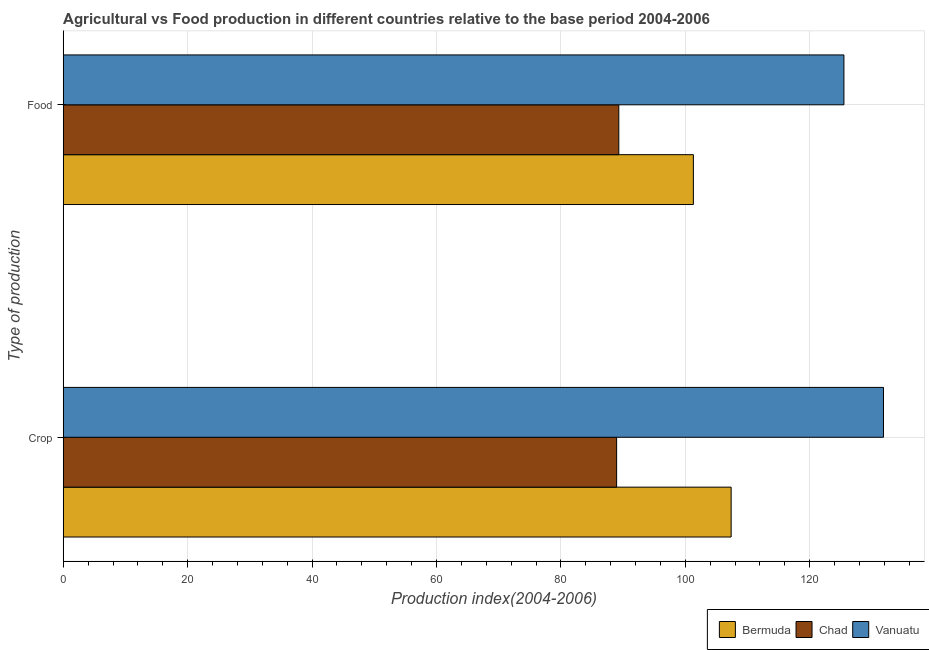How many bars are there on the 2nd tick from the bottom?
Your answer should be very brief. 3. What is the label of the 2nd group of bars from the top?
Keep it short and to the point. Crop. What is the food production index in Vanuatu?
Offer a very short reply. 125.5. Across all countries, what is the maximum crop production index?
Your response must be concise. 131.86. Across all countries, what is the minimum food production index?
Your answer should be very brief. 89.31. In which country was the food production index maximum?
Your answer should be compact. Vanuatu. In which country was the food production index minimum?
Your answer should be compact. Chad. What is the total food production index in the graph?
Your response must be concise. 316.11. What is the difference between the crop production index in Chad and that in Bermuda?
Your response must be concise. -18.41. What is the difference between the crop production index in Chad and the food production index in Vanuatu?
Offer a terse response. -36.54. What is the average food production index per country?
Offer a very short reply. 105.37. What is the difference between the food production index and crop production index in Chad?
Offer a very short reply. 0.35. In how many countries, is the food production index greater than 124 ?
Your answer should be very brief. 1. What is the ratio of the food production index in Vanuatu to that in Bermuda?
Provide a succinct answer. 1.24. Is the food production index in Vanuatu less than that in Bermuda?
Keep it short and to the point. No. What does the 1st bar from the top in Food represents?
Ensure brevity in your answer.  Vanuatu. What does the 1st bar from the bottom in Crop represents?
Provide a succinct answer. Bermuda. How many bars are there?
Keep it short and to the point. 6. Are all the bars in the graph horizontal?
Make the answer very short. Yes. Are the values on the major ticks of X-axis written in scientific E-notation?
Your answer should be very brief. No. Does the graph contain any zero values?
Your answer should be compact. No. Where does the legend appear in the graph?
Ensure brevity in your answer.  Bottom right. How are the legend labels stacked?
Your answer should be very brief. Horizontal. What is the title of the graph?
Make the answer very short. Agricultural vs Food production in different countries relative to the base period 2004-2006. What is the label or title of the X-axis?
Provide a short and direct response. Production index(2004-2006). What is the label or title of the Y-axis?
Provide a short and direct response. Type of production. What is the Production index(2004-2006) in Bermuda in Crop?
Give a very brief answer. 107.37. What is the Production index(2004-2006) of Chad in Crop?
Your response must be concise. 88.96. What is the Production index(2004-2006) in Vanuatu in Crop?
Ensure brevity in your answer.  131.86. What is the Production index(2004-2006) in Bermuda in Food?
Your response must be concise. 101.3. What is the Production index(2004-2006) in Chad in Food?
Provide a short and direct response. 89.31. What is the Production index(2004-2006) of Vanuatu in Food?
Your response must be concise. 125.5. Across all Type of production, what is the maximum Production index(2004-2006) of Bermuda?
Offer a terse response. 107.37. Across all Type of production, what is the maximum Production index(2004-2006) of Chad?
Offer a very short reply. 89.31. Across all Type of production, what is the maximum Production index(2004-2006) in Vanuatu?
Your response must be concise. 131.86. Across all Type of production, what is the minimum Production index(2004-2006) in Bermuda?
Your answer should be very brief. 101.3. Across all Type of production, what is the minimum Production index(2004-2006) in Chad?
Provide a short and direct response. 88.96. Across all Type of production, what is the minimum Production index(2004-2006) of Vanuatu?
Make the answer very short. 125.5. What is the total Production index(2004-2006) in Bermuda in the graph?
Your answer should be compact. 208.67. What is the total Production index(2004-2006) in Chad in the graph?
Give a very brief answer. 178.27. What is the total Production index(2004-2006) of Vanuatu in the graph?
Your response must be concise. 257.36. What is the difference between the Production index(2004-2006) of Bermuda in Crop and that in Food?
Offer a very short reply. 6.07. What is the difference between the Production index(2004-2006) in Chad in Crop and that in Food?
Offer a terse response. -0.35. What is the difference between the Production index(2004-2006) in Vanuatu in Crop and that in Food?
Your answer should be compact. 6.36. What is the difference between the Production index(2004-2006) in Bermuda in Crop and the Production index(2004-2006) in Chad in Food?
Offer a terse response. 18.06. What is the difference between the Production index(2004-2006) of Bermuda in Crop and the Production index(2004-2006) of Vanuatu in Food?
Keep it short and to the point. -18.13. What is the difference between the Production index(2004-2006) in Chad in Crop and the Production index(2004-2006) in Vanuatu in Food?
Offer a terse response. -36.54. What is the average Production index(2004-2006) of Bermuda per Type of production?
Provide a short and direct response. 104.33. What is the average Production index(2004-2006) of Chad per Type of production?
Make the answer very short. 89.14. What is the average Production index(2004-2006) of Vanuatu per Type of production?
Provide a short and direct response. 128.68. What is the difference between the Production index(2004-2006) of Bermuda and Production index(2004-2006) of Chad in Crop?
Ensure brevity in your answer.  18.41. What is the difference between the Production index(2004-2006) of Bermuda and Production index(2004-2006) of Vanuatu in Crop?
Keep it short and to the point. -24.49. What is the difference between the Production index(2004-2006) of Chad and Production index(2004-2006) of Vanuatu in Crop?
Ensure brevity in your answer.  -42.9. What is the difference between the Production index(2004-2006) in Bermuda and Production index(2004-2006) in Chad in Food?
Provide a short and direct response. 11.99. What is the difference between the Production index(2004-2006) of Bermuda and Production index(2004-2006) of Vanuatu in Food?
Make the answer very short. -24.2. What is the difference between the Production index(2004-2006) of Chad and Production index(2004-2006) of Vanuatu in Food?
Make the answer very short. -36.19. What is the ratio of the Production index(2004-2006) in Bermuda in Crop to that in Food?
Keep it short and to the point. 1.06. What is the ratio of the Production index(2004-2006) in Vanuatu in Crop to that in Food?
Provide a succinct answer. 1.05. What is the difference between the highest and the second highest Production index(2004-2006) in Bermuda?
Your response must be concise. 6.07. What is the difference between the highest and the second highest Production index(2004-2006) in Vanuatu?
Your response must be concise. 6.36. What is the difference between the highest and the lowest Production index(2004-2006) of Bermuda?
Offer a very short reply. 6.07. What is the difference between the highest and the lowest Production index(2004-2006) of Chad?
Offer a very short reply. 0.35. What is the difference between the highest and the lowest Production index(2004-2006) in Vanuatu?
Ensure brevity in your answer.  6.36. 